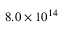<formula> <loc_0><loc_0><loc_500><loc_500>8 . 0 \times 1 0 ^ { 1 4 }</formula> 